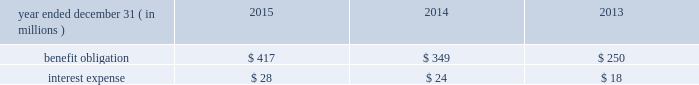Nbcuniversal media , llc our consolidated balance sheet also includes the assets and liabilities of certain legacy pension plans , as well as the assets and liabilities for pension plans of certain foreign subsidiaries .
As of december 31 , 2015 and 2014 , the benefit obligations associated with these plans exceeded the fair value of the plan assets by $ 67 million and $ 51 million , respectively .
Other employee benefits deferred compensation plans we maintain unfunded , nonqualified deferred compensation plans for certain members of management ( each , a 201cparticipant 201d ) .
The amount of compensation deferred by each participant is based on participant elections .
Participants in the plan designate one or more valuation funds , independently established funds or indices that are used to determine the amount of investment gain or loss in the participant 2019s account .
Additionally , certain of our employees participate in comcast 2019s unfunded , nonqualified deferred compensa- tion plan .
The amount of compensation deferred by each participant is based on participant elections .
Participant accounts are credited with income primarily based on a fixed annual rate .
In the case of both deferred compensation plans , participants are eligible to receive distributions from their account based on elected deferral periods that are consistent with the plans and applicable tax law .
The table below presents the benefit obligation and interest expense for our deferred compensation plans. .
Retirement investment plans we sponsor several 401 ( k ) defined contribution retirement plans that allow eligible employees to contribute a portion of their compensation through payroll deductions in accordance with specified plan guidelines .
We make contributions to the plans that include matching a percentage of the employees 2019 contributions up to certain limits .
In 2015 , 2014 and 2013 , expenses related to these plans totaled $ 174 million , $ 165 million and $ 152 million , respectively .
Multiemployer benefit plans we participate in various multiemployer benefit plans , including pension and postretirement benefit plans , that cover some of our employees and temporary employees who are represented by labor unions .
We also partic- ipate in other multiemployer benefit plans that provide health and welfare and retirement savings benefits to active and retired participants .
We make periodic contributions to these plans in accordance with the terms of applicable collective bargaining agreements and laws but do not sponsor or administer these plans .
We do not participate in any multiemployer benefit plans for which we consider our contributions to be individually significant , and the largest plans in which we participate are funded at a level of 80% ( 80 % ) or greater .
In 2015 , 2014 and 2013 , the total contributions we made to multiemployer pension plans were $ 77 million , $ 58 million and $ 59 million , respectively .
In 2015 , 2014 and 2013 , the total contributions we made to multi- employer postretirement and other benefit plans were $ 119 million , $ 125 million and $ 98 million , respectively .
If we cease to be obligated to make contributions or were to otherwise withdraw from participation in any of these plans , applicable law would require us to fund our allocable share of the unfunded vested benefits , which is known as a withdrawal liability .
In addition , actions taken by other participating employers may lead to adverse changes in the financial condition of one of these plans , which could result in an increase in our withdrawal liability .
Comcast 2015 annual report on form 10-k 166 .
What was the ratio of the excess of the benefits over their fair value in 2015 to 2014 as of december 31 , 2015 and 2014 , the benefit obligations associated with these plans exceeded the fair value of the plan assets by $ 67 million and $ 51 million , respectively .? 
Computations: (67 / 51)
Answer: 1.31373. 